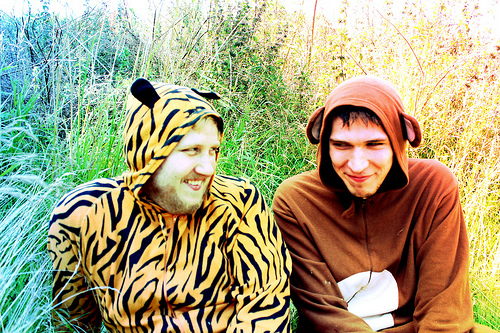<image>
Is the monkey man to the left of the tiger man? Yes. From this viewpoint, the monkey man is positioned to the left side relative to the tiger man. 